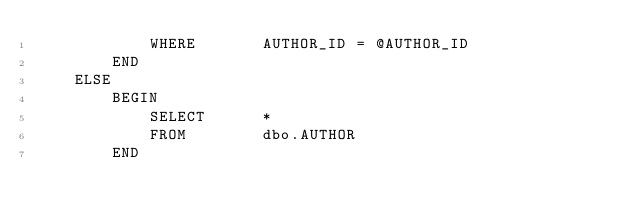<code> <loc_0><loc_0><loc_500><loc_500><_SQL_>            WHERE       AUTHOR_ID = @AUTHOR_ID
        END
    ELSE
        BEGIN
            SELECT      *
            FROM        dbo.AUTHOR
        END</code> 